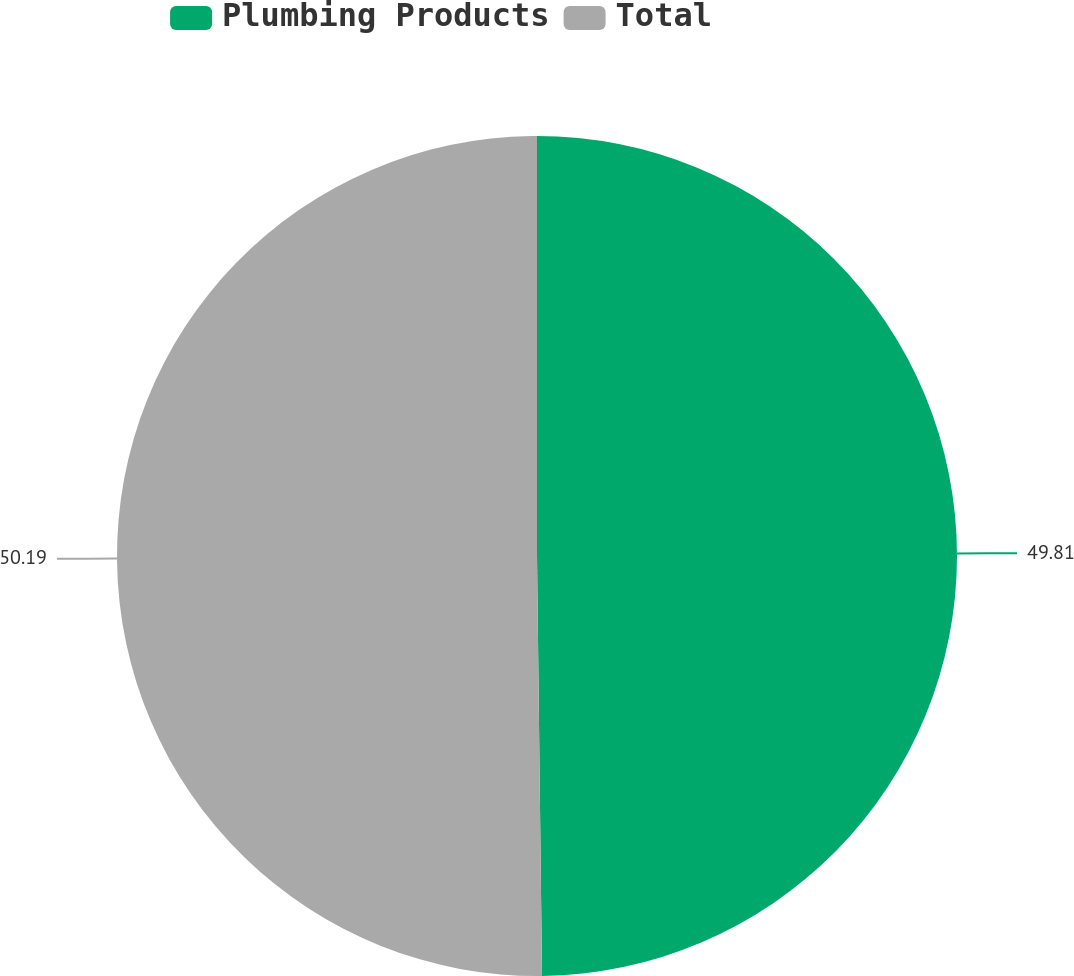Convert chart. <chart><loc_0><loc_0><loc_500><loc_500><pie_chart><fcel>Plumbing Products<fcel>Total<nl><fcel>49.81%<fcel>50.19%<nl></chart> 